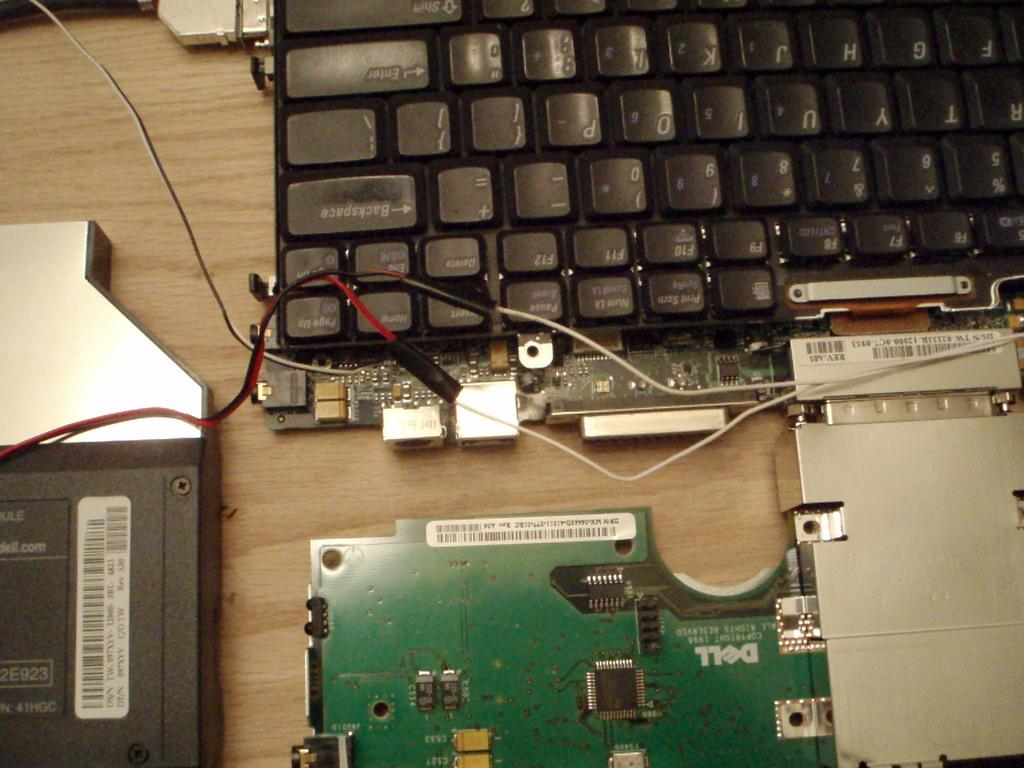<image>
Present a compact description of the photo's key features. Dell computer parts are attached by wires and tape to the guts of a keyboard. 